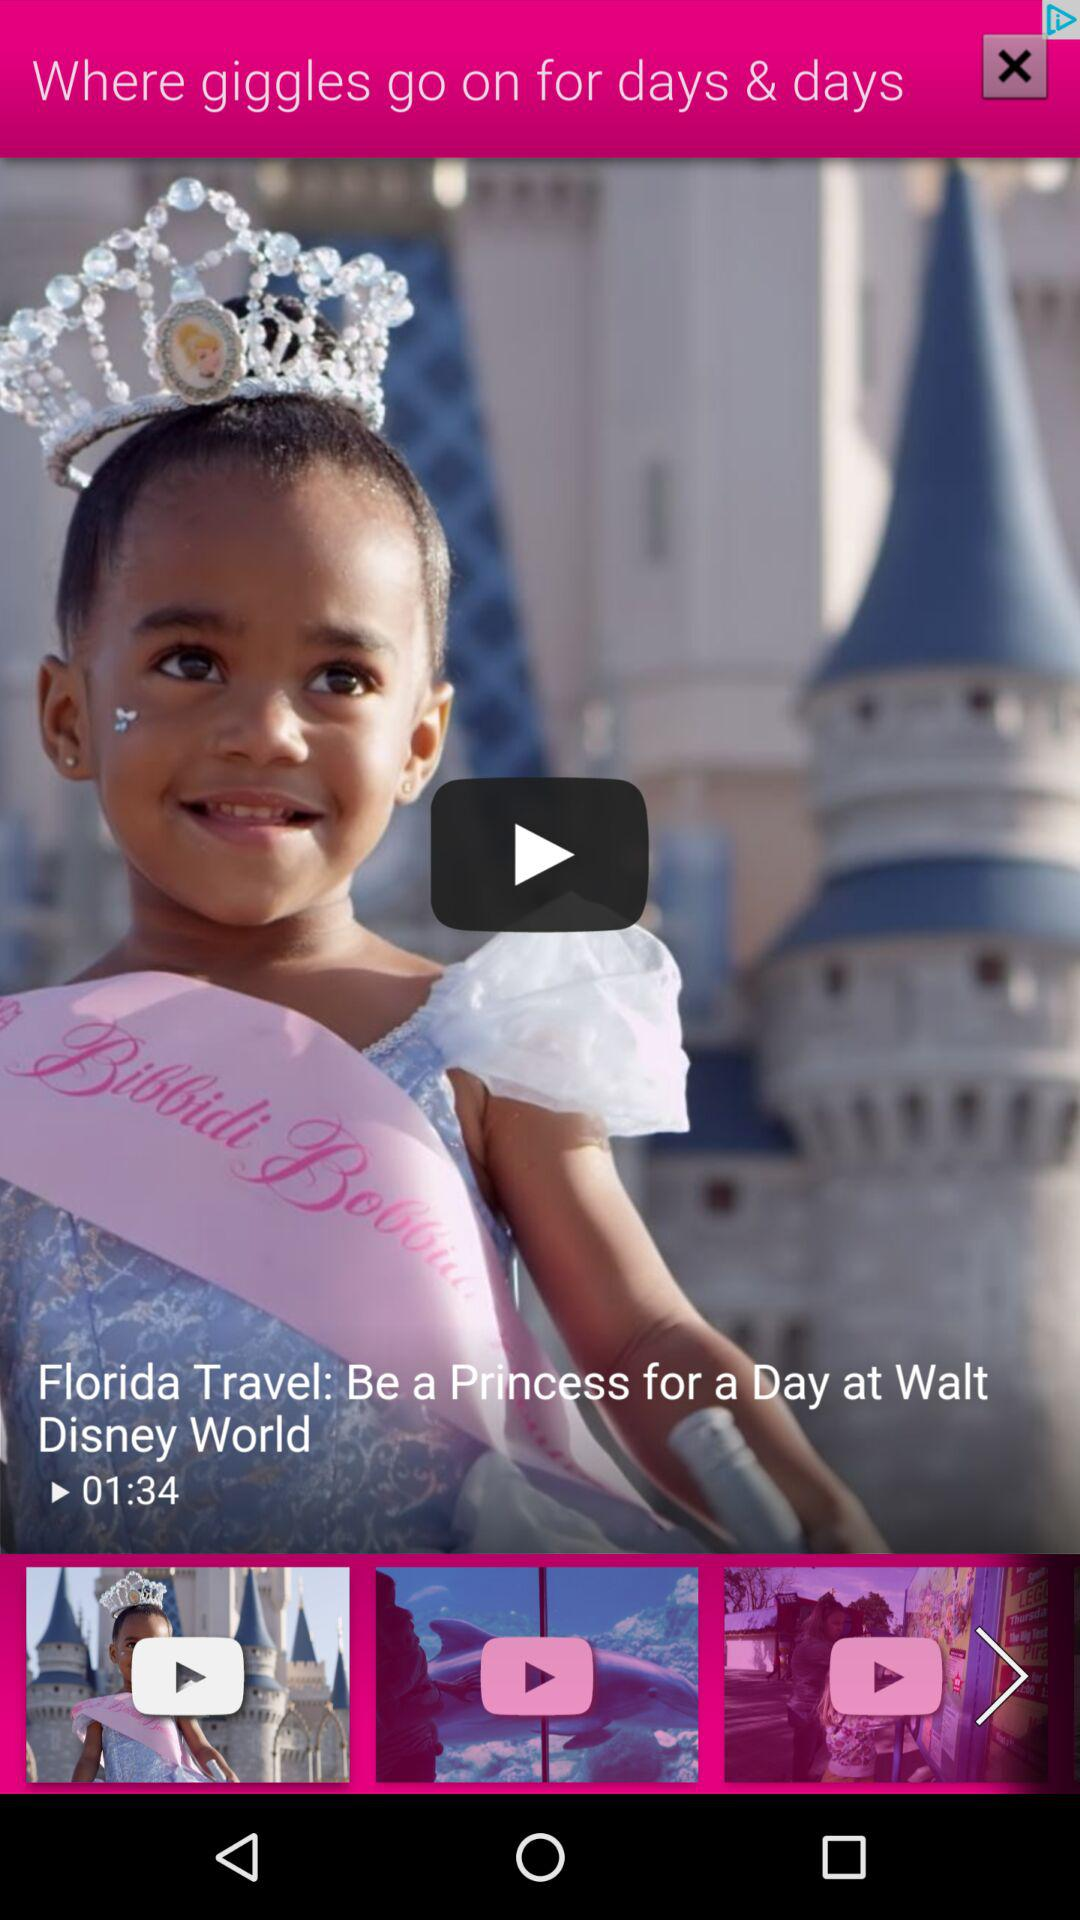How many videos are shown?
Answer the question using a single word or phrase. 3 